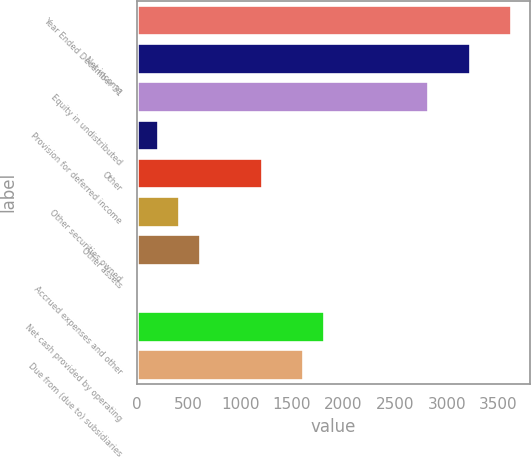<chart> <loc_0><loc_0><loc_500><loc_500><bar_chart><fcel>Year Ended December 31<fcel>Net income<fcel>Equity in undistributed<fcel>Provision for deferred income<fcel>Other<fcel>Other securities owned<fcel>Other assets<fcel>Accrued expenses and other<fcel>Net cash provided by operating<fcel>Due from (due to) subsidiaries<nl><fcel>3623.8<fcel>3221.6<fcel>2819.4<fcel>205.1<fcel>1210.6<fcel>406.2<fcel>607.3<fcel>4<fcel>1813.9<fcel>1612.8<nl></chart> 